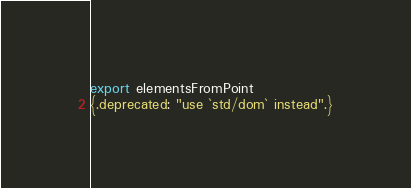<code> <loc_0><loc_0><loc_500><loc_500><_Nim_>export elementsFromPoint
{.deprecated: "use `std/dom` instead".}
</code> 